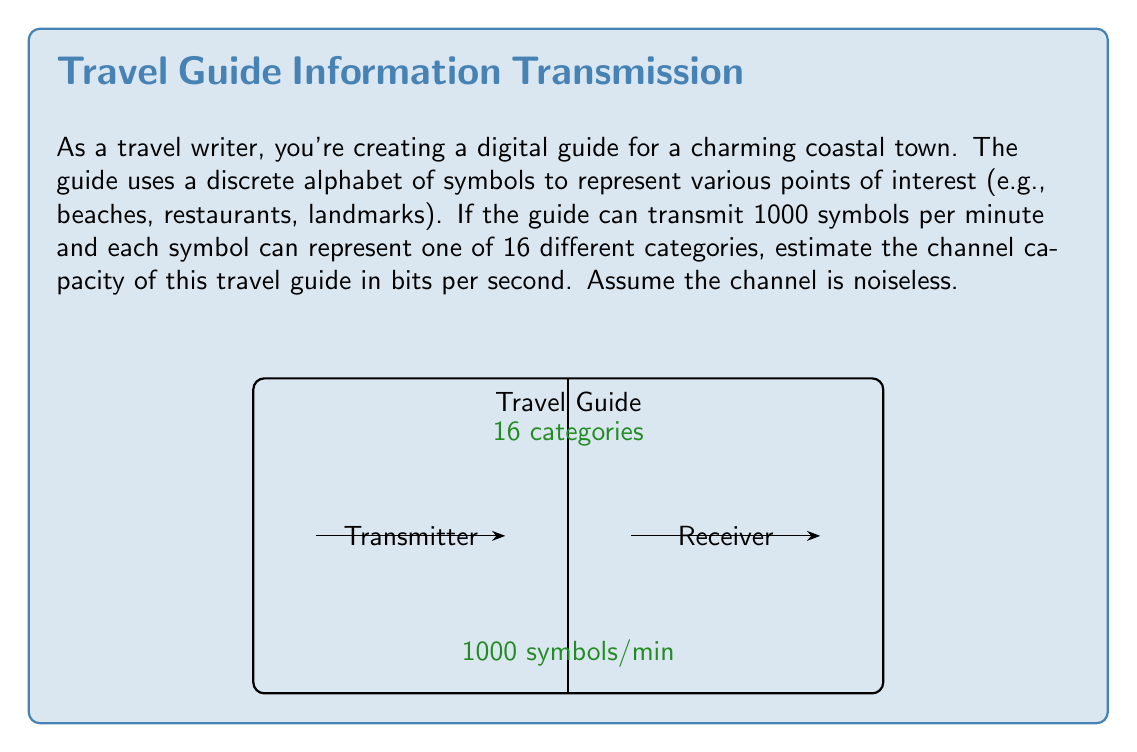What is the answer to this math problem? To estimate the channel capacity of the travel guide, we'll use Shannon's channel capacity formula for a noiseless channel:

$$ C = R \log_2 M $$

Where:
- $C$ is the channel capacity in bits per second
- $R$ is the symbol rate (symbols per second)
- $M$ is the number of possible symbols in the alphabet

Step 1: Calculate the symbol rate (R)
The guide transmits 1000 symbols per minute.
$R = 1000 \text{ symbols/minute} \times \frac{1 \text{ minute}}{60 \text{ seconds}} = \frac{50}{3} \text{ symbols/second}$

Step 2: Determine the number of possible symbols (M)
Each symbol can represent one of 16 different categories, so $M = 16$.

Step 3: Apply Shannon's formula
$$ C = \frac{50}{3} \log_2 16 $$

Step 4: Simplify
$\log_2 16 = 4$ (since $2^4 = 16$)

$$ C = \frac{50}{3} \times 4 = \frac{200}{3} \text{ bits/second} $$

Step 5: Calculate the final result
$\frac{200}{3} \approx 66.67 \text{ bits/second}$
Answer: $\frac{200}{3} \approx 66.67 \text{ bits/second}$ 